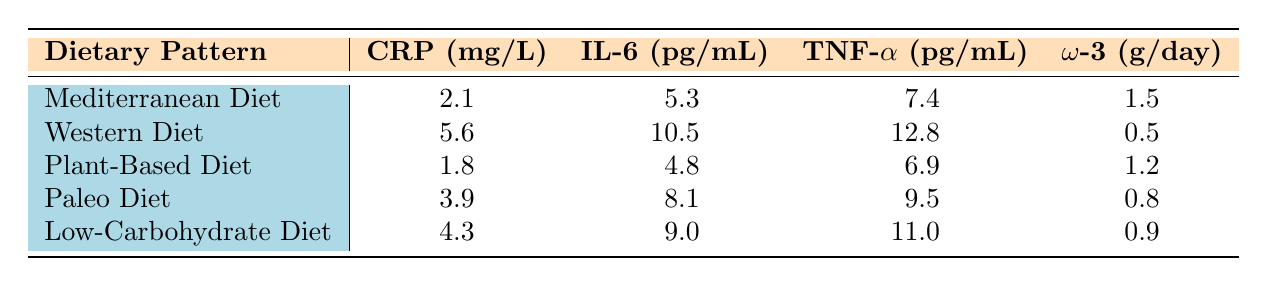What is the C-Reactive Protein level for the Mediterranean Diet? The C-Reactive Protein level for the Mediterranean Diet is stated in the table as 2.1 mg/L.
Answer: 2.1 mg/L Which dietary pattern has the highest level of Interleukin-6? By comparing the Interleukin-6 values listed for each dietary pattern, the Western Diet has the highest level at 10.5 pg/mL.
Answer: Western Diet What is the average level of Tumor Necrosis Factor-alpha across all dietary patterns? The Tumor Necrosis Factor-alpha values are 7.4, 12.8, 6.9, 9.5, and 11.0 for the five dietary patterns. Summing these gives 7.4 + 12.8 + 6.9 + 9.5 + 11.0 = 47.6. Dividing by the number of patterns (5) gives an average of 47.6 / 5 = 9.52 pg/mL.
Answer: 9.52 pg/mL Does the Plant-Based Diet show lower levels of C-Reactive Protein than the Paleo Diet? The C-Reactive Protein level for the Plant-Based Diet is 1.8 mg/L, while for the Paleo Diet it is 3.9 mg/L. Since 1.8 is less than 3.9, the Plant-Based Diet does indeed show lower levels.
Answer: Yes What is the difference in Omega-3 fatty acids intake between the Western Diet and the Mediterranean Diet? The Omega-3 fatty acids intake in the Western Diet is 0.5 g/day, and for the Mediterranean Diet, it is 1.5 g/day. The difference is calculated as 1.5 - 0.5 = 1.0 g/day.
Answer: 1.0 g/day Which dietary pattern has the lowest levels of Tumor Necrosis Factor-alpha? By reviewing the Tumor Necrosis Factor-alpha values, the Plant-Based Diet has the lowest level at 6.9 pg/mL compared to the others.
Answer: Plant-Based Diet Is it true that all dietary patterns have Omega-3 intake below 2 g/day? Checking the Omega-3 intake values reveals that the Mediterranean Diet has a value of 1.5 g/day, which is below 2 g/day, and the Plant-Based Diet has 1.2 g/day, the Paleo Diet has 0.8 g/day, and the Low-Carbohydrate Diet has 0.9 g/day, while the Western Diet is 0.5 g/day. Therefore, all patterns do have an intake below 2 g/day.
Answer: Yes What is the total cumulative amount of C-Reactive Protein across all dietary patterns? The C-Reactive Protein levels are 2.1, 5.6, 1.8, 3.9, and 4.3. Summing these values gives 2.1 + 5.6 + 1.8 + 3.9 + 4.3 = 17.7 mg/L.
Answer: 17.7 mg/L 